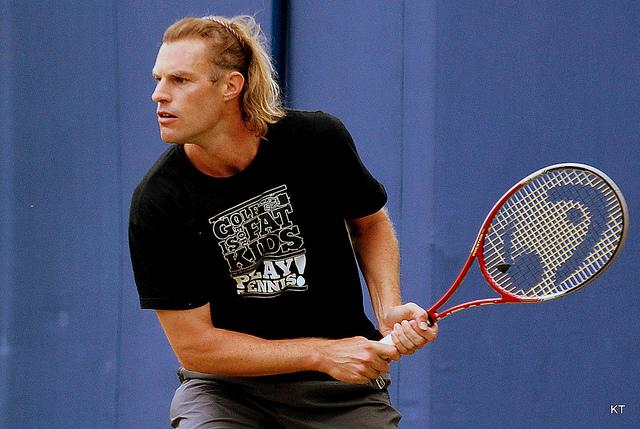What color is his tennis racket?
Short answer required. Red. Is this man wearing any visible jewelry?
Give a very brief answer. No. What is the man playing?
Concise answer only. Tennis. What color is his racket?
Quick response, please. Red. What is the design on the net of her tennis racket?
Short answer required. Yin yang. Where is the letter P?
Give a very brief answer. Shirt. 